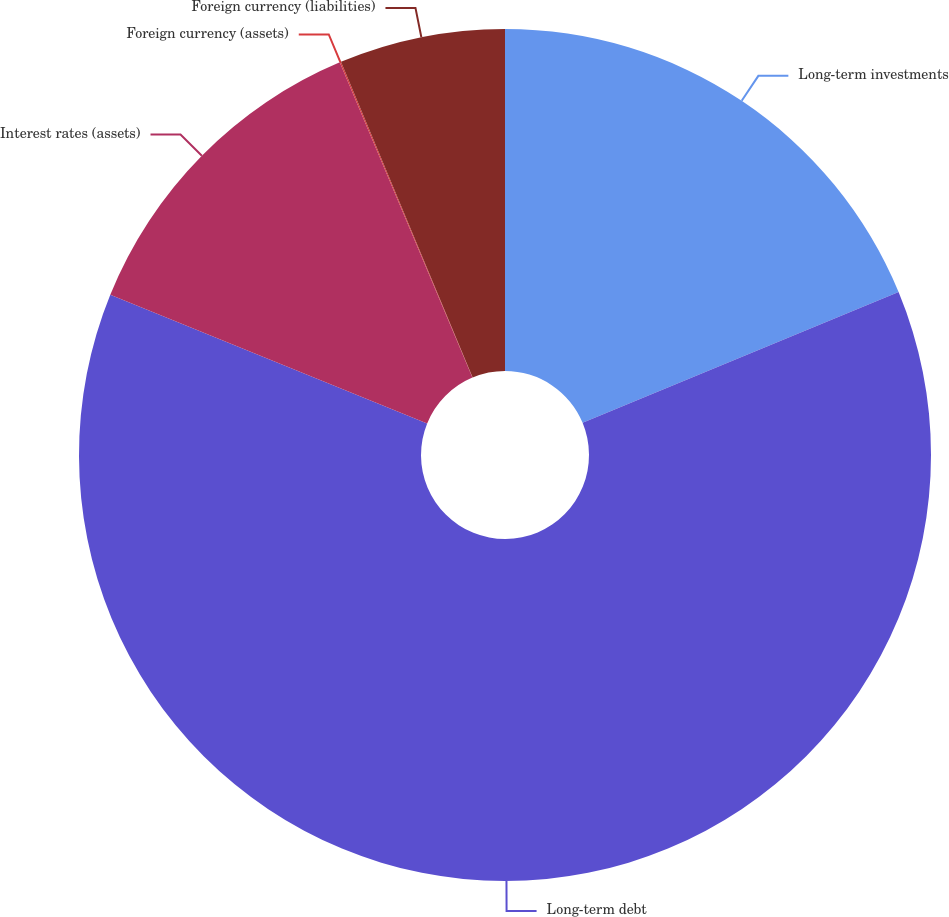<chart> <loc_0><loc_0><loc_500><loc_500><pie_chart><fcel>Long-term investments<fcel>Long-term debt<fcel>Interest rates (assets)<fcel>Foreign currency (assets)<fcel>Foreign currency (liabilities)<nl><fcel>18.75%<fcel>62.38%<fcel>12.52%<fcel>0.05%<fcel>6.29%<nl></chart> 